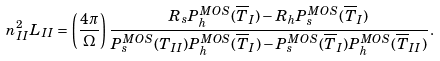Convert formula to latex. <formula><loc_0><loc_0><loc_500><loc_500>n ^ { 2 } _ { I I } L _ { I I } = \left ( \frac { 4 \pi } { \Omega } \right ) \frac { R _ { s } P ^ { M O S } _ { h } ( \overline { T } _ { I } ) - R _ { h } P ^ { M O S } _ { s } ( \overline { T } _ { I } ) } { P ^ { M O S } _ { s } ( T _ { I I } ) P ^ { M O S } _ { h } ( \overline { T } _ { I } ) - P ^ { M O S } _ { s } ( \overline { T } _ { I } ) P ^ { M O S } _ { h } ( \overline { T } _ { I I } ) } \, .</formula> 